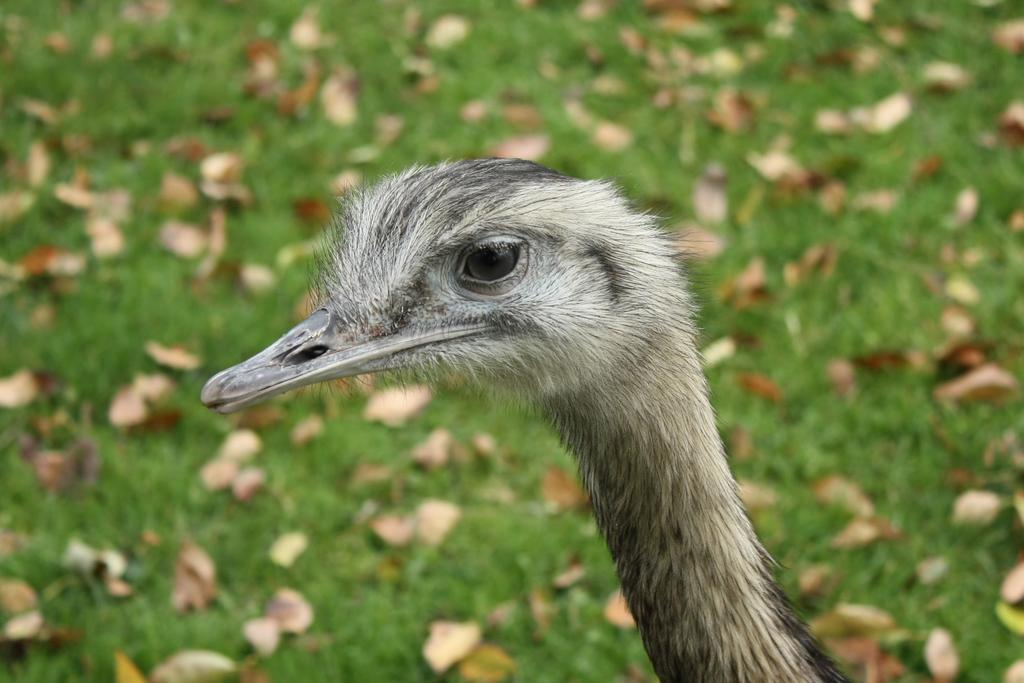What type of animal can be seen in the image? There is a bird in the image. Can you describe the bird's eye? The bird has a black color eye. What can be found in the grass in the image? There are dried leaves in the grass in the image. How many parents does the cobweb have in the image? There is no cobweb present in the image, so it is not possible to determine the number of parents it might have. 